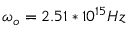Convert formula to latex. <formula><loc_0><loc_0><loc_500><loc_500>\omega _ { o } = 2 . 5 1 * 1 0 ^ { 1 5 } H z</formula> 